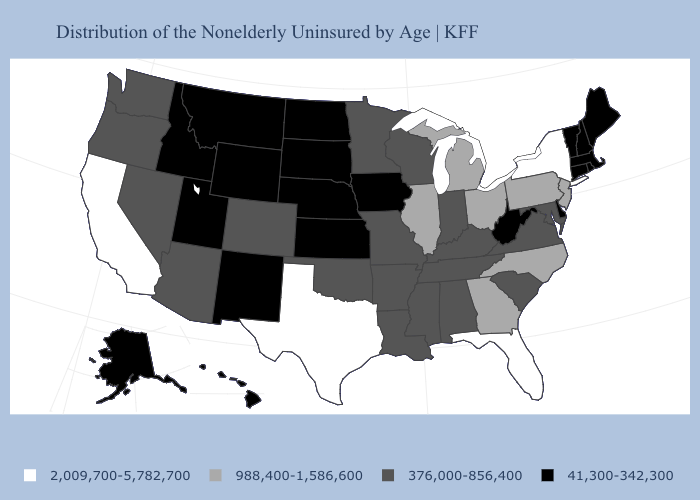What is the value of Massachusetts?
Concise answer only. 41,300-342,300. Does California have the lowest value in the USA?
Keep it brief. No. Among the states that border Oregon , which have the lowest value?
Write a very short answer. Idaho. What is the value of New Hampshire?
Concise answer only. 41,300-342,300. Does Illinois have the same value as Michigan?
Short answer required. Yes. Among the states that border Oklahoma , does Texas have the highest value?
Short answer required. Yes. What is the highest value in the USA?
Short answer required. 2,009,700-5,782,700. What is the highest value in the South ?
Write a very short answer. 2,009,700-5,782,700. What is the value of Oregon?
Quick response, please. 376,000-856,400. What is the highest value in the USA?
Keep it brief. 2,009,700-5,782,700. Which states have the lowest value in the USA?
Write a very short answer. Alaska, Connecticut, Delaware, Hawaii, Idaho, Iowa, Kansas, Maine, Massachusetts, Montana, Nebraska, New Hampshire, New Mexico, North Dakota, Rhode Island, South Dakota, Utah, Vermont, West Virginia, Wyoming. What is the highest value in the USA?
Be succinct. 2,009,700-5,782,700. Does Texas have the highest value in the USA?
Keep it brief. Yes. Among the states that border Arizona , does Colorado have the lowest value?
Answer briefly. No. Name the states that have a value in the range 2,009,700-5,782,700?
Short answer required. California, Florida, New York, Texas. 